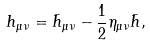<formula> <loc_0><loc_0><loc_500><loc_500>h _ { \mu \nu } = \bar { h } _ { \mu \nu } - \frac { 1 } { 2 } \eta _ { \mu \nu } \bar { h } ,</formula> 